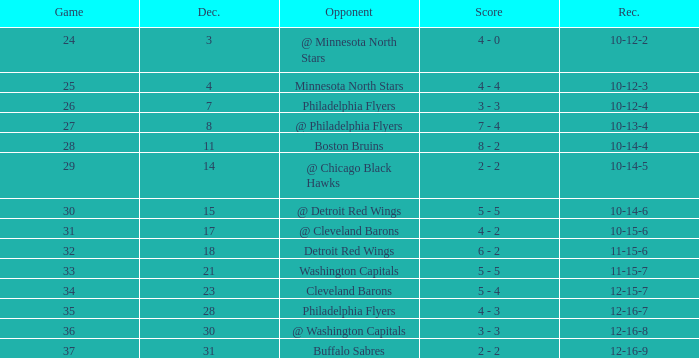What is the lowest December, when Score is "4 - 4"? 4.0. 